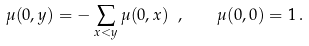<formula> <loc_0><loc_0><loc_500><loc_500>\mu ( 0 , y ) = - \sum _ { x < y } \mu ( 0 , x ) \ , \quad \mu ( 0 , 0 ) = 1 \, .</formula> 